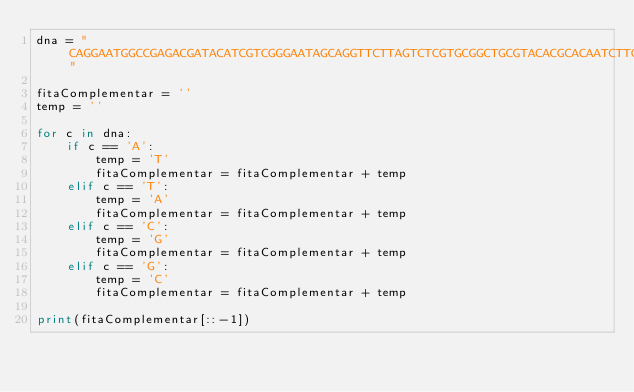<code> <loc_0><loc_0><loc_500><loc_500><_Python_>dna = "CAGGAATGGCCGAGACGATACATCGTCGGGAATAGCAGGTTCTTAGTCTCGTGCGGCTGCGTACACGCACAATCTTGAACAGACCACATGTAGGGGCCGCGATGTCAAGTACGGCTACAGTACCCATGTCGTCAGTAGCAACATGGGAAGCTATGGCACCCAATCACACGGTTCCCCCTTGAGAATAGGGATTAGGCTCTTCCCTAGCTTATTGGCATGCTGCATATTGCCATACCGTACTGAAATTAAGTGTTCGATGGCAAGGGGGTTTACCAAGATCTATGACTCTGCACATCGATGAAGGTGGATCCCGGGCTCACTCGTTCCAGATATCATCCGATGGACGTACTGGTGGATCGAAGTTTAGGGTCGTACACTTGGTTATTCGACATAACATGTTACTGGGTAACGATTGATACACCTGGATACATCAGCGACCACGCACGGGAAGGATGTGGTTATGCGAATGTTTAAATCGTATGCGGGACCTAATAAGCCTTCCATTGTAGATCTCCTTGGCCAGTTTTATAGACATAGCTAGCTGCTTACCAGAGCGACGCAATGTATGCGGAGGACCACACTCAAAAAAGACTTCGTCGGGTAGCCTTGGATTGAGGTTAGACTCCGATGACTTTCATTCCTGCGACCTGCTCAGAGTGGTGCGCAGGTTACAAGTGGAGTGGACTAAATTCCAATGAATTTGTAGCAGATAGTAACCTCAGGGAAGATAGGTCACACTTAACGGTTAAAGAAGCTCATCAGTCAGGTTAGCCTGACCGGATGAGTTTGGCCCATAATTGCAGACCGGGATTAGAATGCAATATATCGGATGGATTAGCTTTCGAGCCTTTACCGTAGGCCACGGAG"

fitaComplementar = ''
temp = ''

for c in dna:
    if c == 'A':
        temp = 'T'
        fitaComplementar = fitaComplementar + temp
    elif c == 'T':
        temp = 'A'
        fitaComplementar = fitaComplementar + temp
    elif c == 'C':
        temp = 'G'
        fitaComplementar = fitaComplementar + temp
    elif c == 'G':
        temp = 'C'
        fitaComplementar = fitaComplementar + temp

print(fitaComplementar[::-1])</code> 